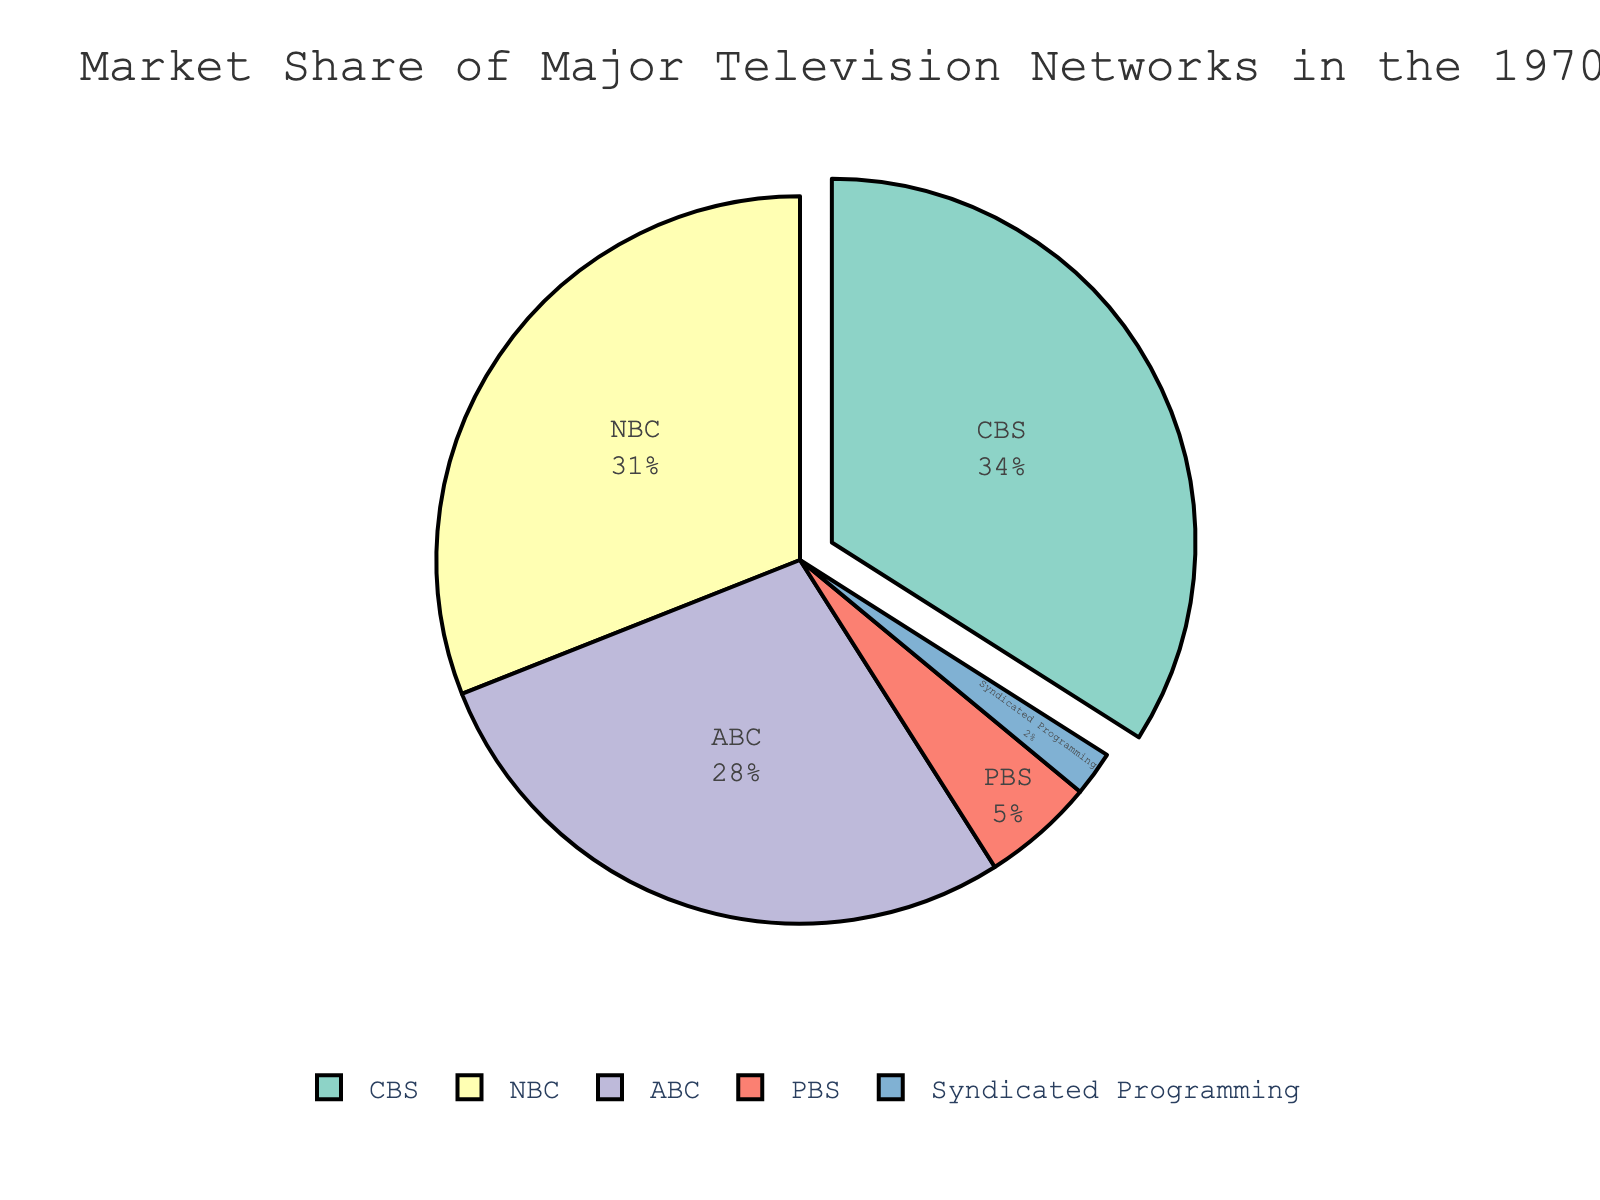What network had the largest market share in the 1970s? CBS had the largest market share as its slice in the pie chart is the largest, and the label shows it holds 34% of the market.
Answer: CBS What is the combined market share of NBC and ABC? NBC's market share is 31% and ABC's is 28%. Adding them together, 31 + 28 = 59%.
Answer: 59% How much larger is CBS's market share compared to PBS's? CBS's market share is 34% and PBS's is 5%. The difference is 34 - 5 = 29%.
Answer: 29% Which networks have a market share greater than 25%? CBS, NBC, and ABC each have market shares of 34%, 31%, and 28%, respectively, all of which are greater than 25%.
Answer: CBS, NBC, ABC What percentage of the market is held by non-commercial networks (PBS and Syndicated Programming)? PBS has a 5% share and Syndicated Programming has a 2% share. Adding them together, 5 + 2 = 7%.
Answer: 7% Which network had the smallest market share? The smallest slice in the pie chart corresponds to Syndicated Programming, which has a market share of 2%.
Answer: Syndicated Programming How much larger is the combined market share of CBS and NBC compared to ABC? The combined market share of CBS and NBC is 34 + 31 = 65%. ABC's market share is 28%. The difference is 65 - 28 = 37%.
Answer: 37% Between CBS and NBC, which network had a closer market share to ABC? CBS has a market share of 34%, NBC has 31%, and ABC has 28%. The difference between CBS and ABC is 34 - 28 = 6%, and the difference between NBC and ABC is 31 - 28 = 3%. Therefore, NBC is closer to ABC by market share.
Answer: NBC If the market share of ABC and PBS were combined, how would it compare with NBC's market share? Combining ABC's 28% with PBS's 5%, we get 28 + 5 = 33%. NBC has a market share of 31%, so ABC + PBS (33%) has a larger share compared to NBC's 31%.
Answer: 33% is greater than 31% 